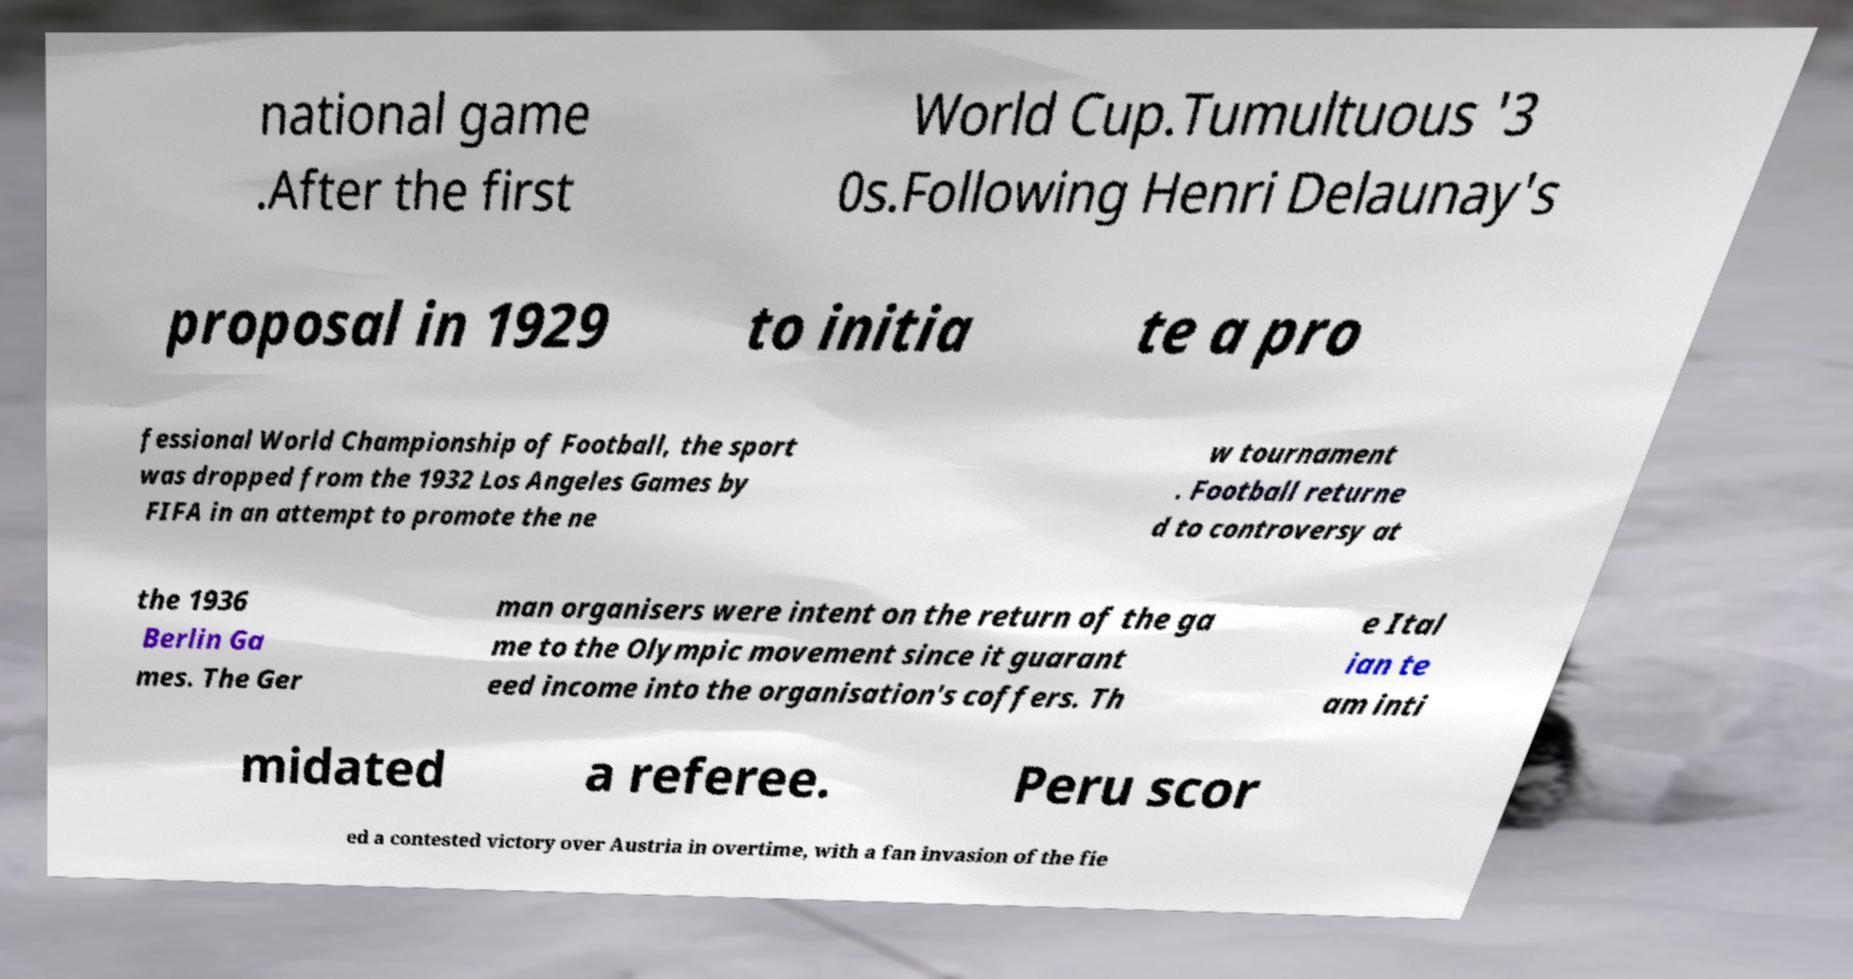Can you accurately transcribe the text from the provided image for me? national game .After the first World Cup.Tumultuous '3 0s.Following Henri Delaunay's proposal in 1929 to initia te a pro fessional World Championship of Football, the sport was dropped from the 1932 Los Angeles Games by FIFA in an attempt to promote the ne w tournament . Football returne d to controversy at the 1936 Berlin Ga mes. The Ger man organisers were intent on the return of the ga me to the Olympic movement since it guarant eed income into the organisation's coffers. Th e Ital ian te am inti midated a referee. Peru scor ed a contested victory over Austria in overtime, with a fan invasion of the fie 